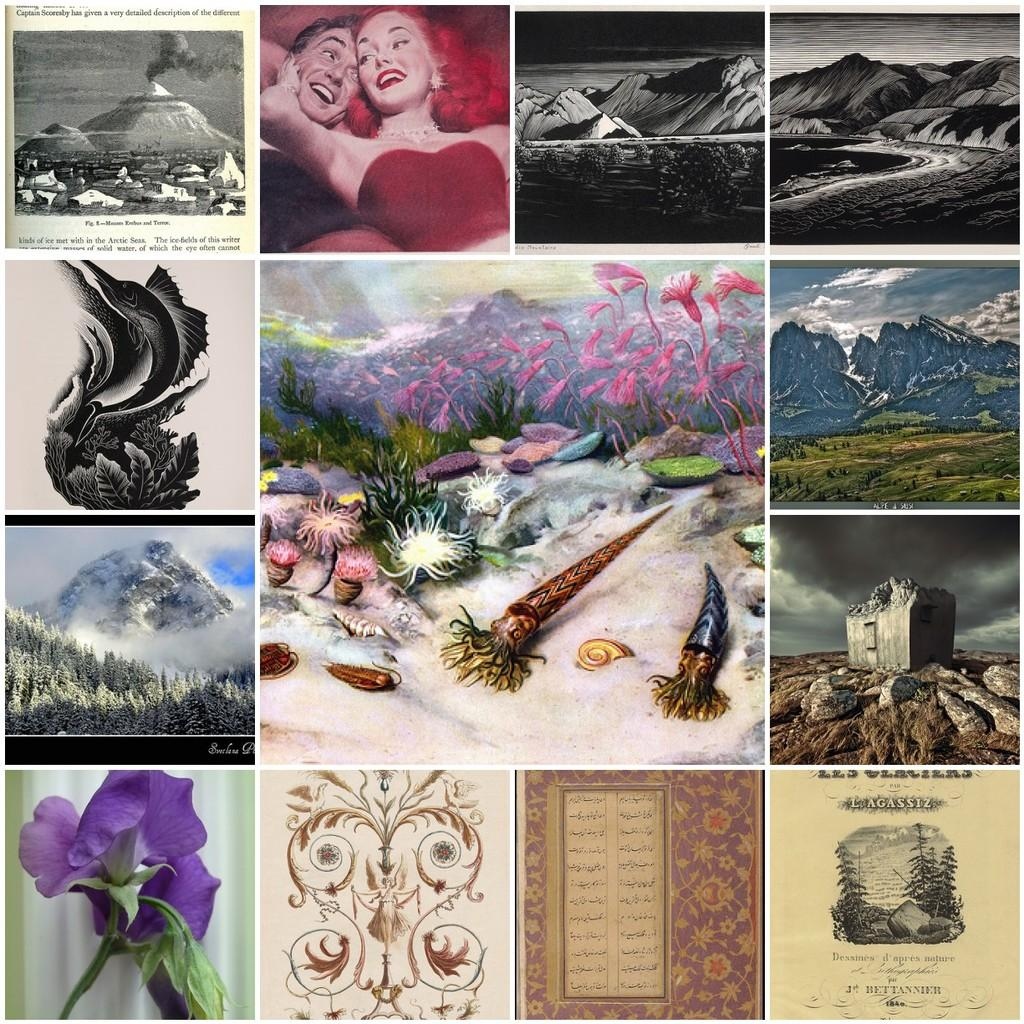What type of artwork is depicted in the image? The image is a collage. What types of subjects are included in the collage? There are images of persons, mountains, trees, and flowers in the collage. Can you tell me how many times the calculator is used in the collage? There is no calculator present in the collage; it is a collection of images featuring persons, mountains, trees, and flowers. 